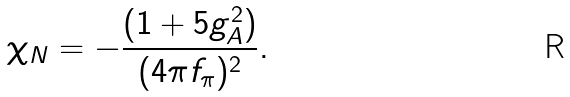<formula> <loc_0><loc_0><loc_500><loc_500>\chi _ { N } = - \frac { ( 1 + 5 g _ { A } ^ { 2 } ) } { ( 4 \pi f _ { \pi } ) ^ { 2 } } .</formula> 